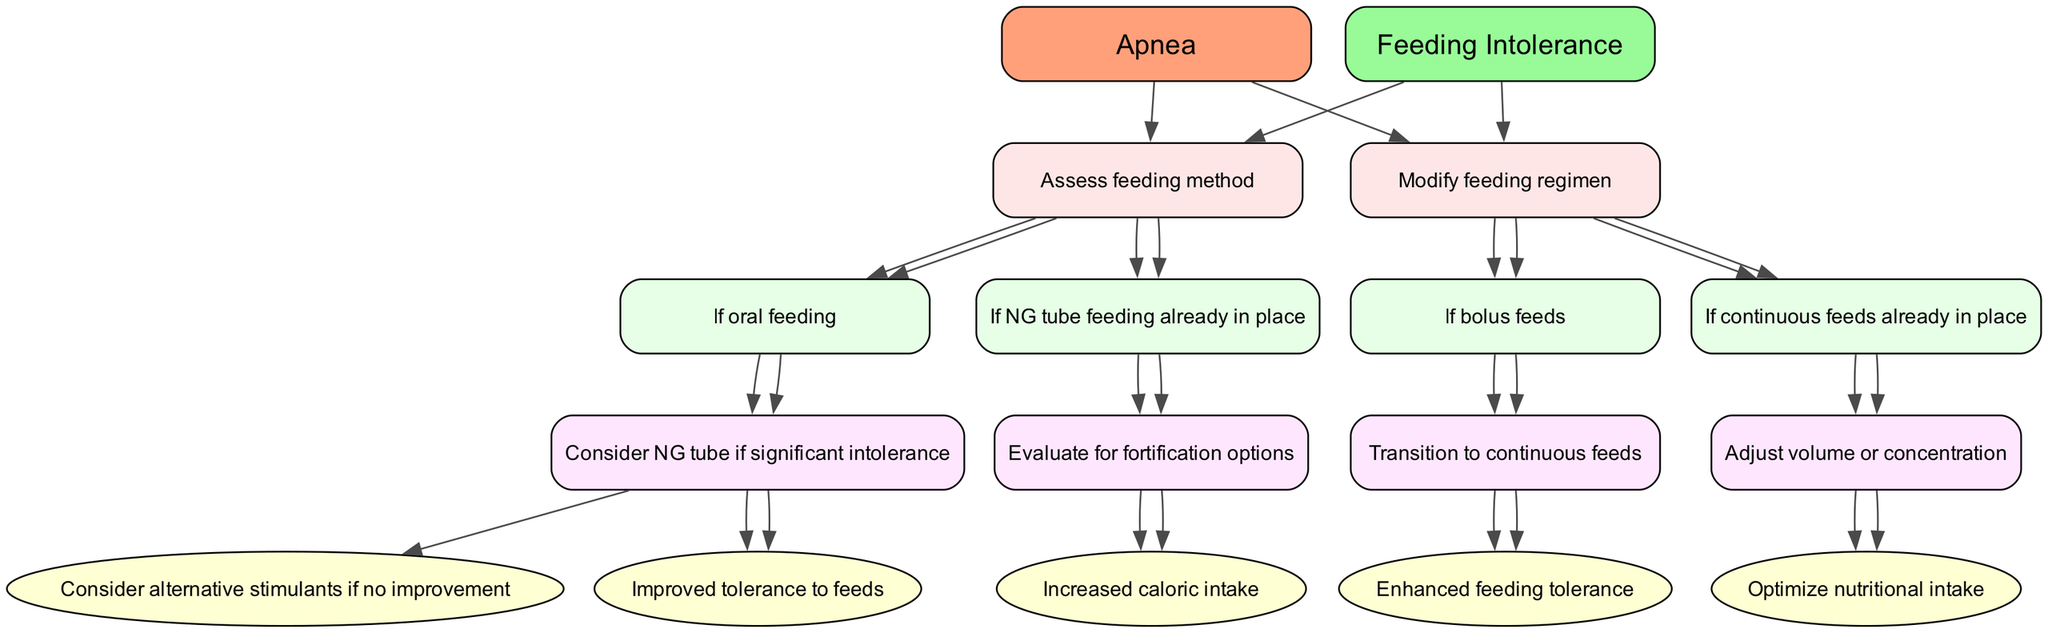What is the first complication listed in the decision tree? The diagram starts with the complication of apnea, which is the first node representing a health issue needing management.
Answer: Apnea How many main options are there for managing apnea? There are two main options listed for managing apnea: "Monitor for frequency and severity" and "Consider non-invasive ventilation."
Answer: Two What is the outcome if frequent apnea episodes are observed and caffeine citrate is administered? The diagram specifies that administering caffeine citrate leads to the outcome of reduced apnea episodes, meaning that this is a positive result of the intervention.
Answer: Reduced apnea episodes What action is suggested if there are infrequent episodes of apnea? The diagram indicates that if there are infrequent apnea episodes, the suggested action is to continue routine monitoring, allowing for a conservative approach to care.
Answer: Continue routine monitoring What is the next step if the NG tube feeding method is found to be in place? If the NG tube feeding method is already in place, the next step is to evaluate for fortification options, which implies checking if the feeding can be enhanced nutritionally.
Answer: Evaluate for fortification options If bolus feeds are currently being used, what action should be taken next? The diagram suggests transitioning to continuous feeds if bolus feeds are being used, indicating a shift in how feeding will be administered for better tolerance.
Answer: Transition to continuous feeds What is the expected outcome after transitioning to continuous feeds? The expected outcome listed in the diagram after transitioning to continuous feeds is enhanced feeding tolerance, which indicates that this change can improve how well the infant is able to handle feeding.
Answer: Enhanced feeding tolerance What are the follow-up actions after administering caffeine citrate if there is no improvement? The diagram states that if there is no improvement after administering caffeine citrate, the follow-up action is to consider alternative stimulants, indicating a need to seek other options.
Answer: Consider alternative stimulants What is the action taken if non-invasive ventilation is found to be ineffective? If non-invasive ventilation is determined to be ineffective, the diagram suggests evaluating for mechanical ventilation, which means moving to a more advanced level of support for the infant.
Answer: Evaluate for mechanical ventilation 